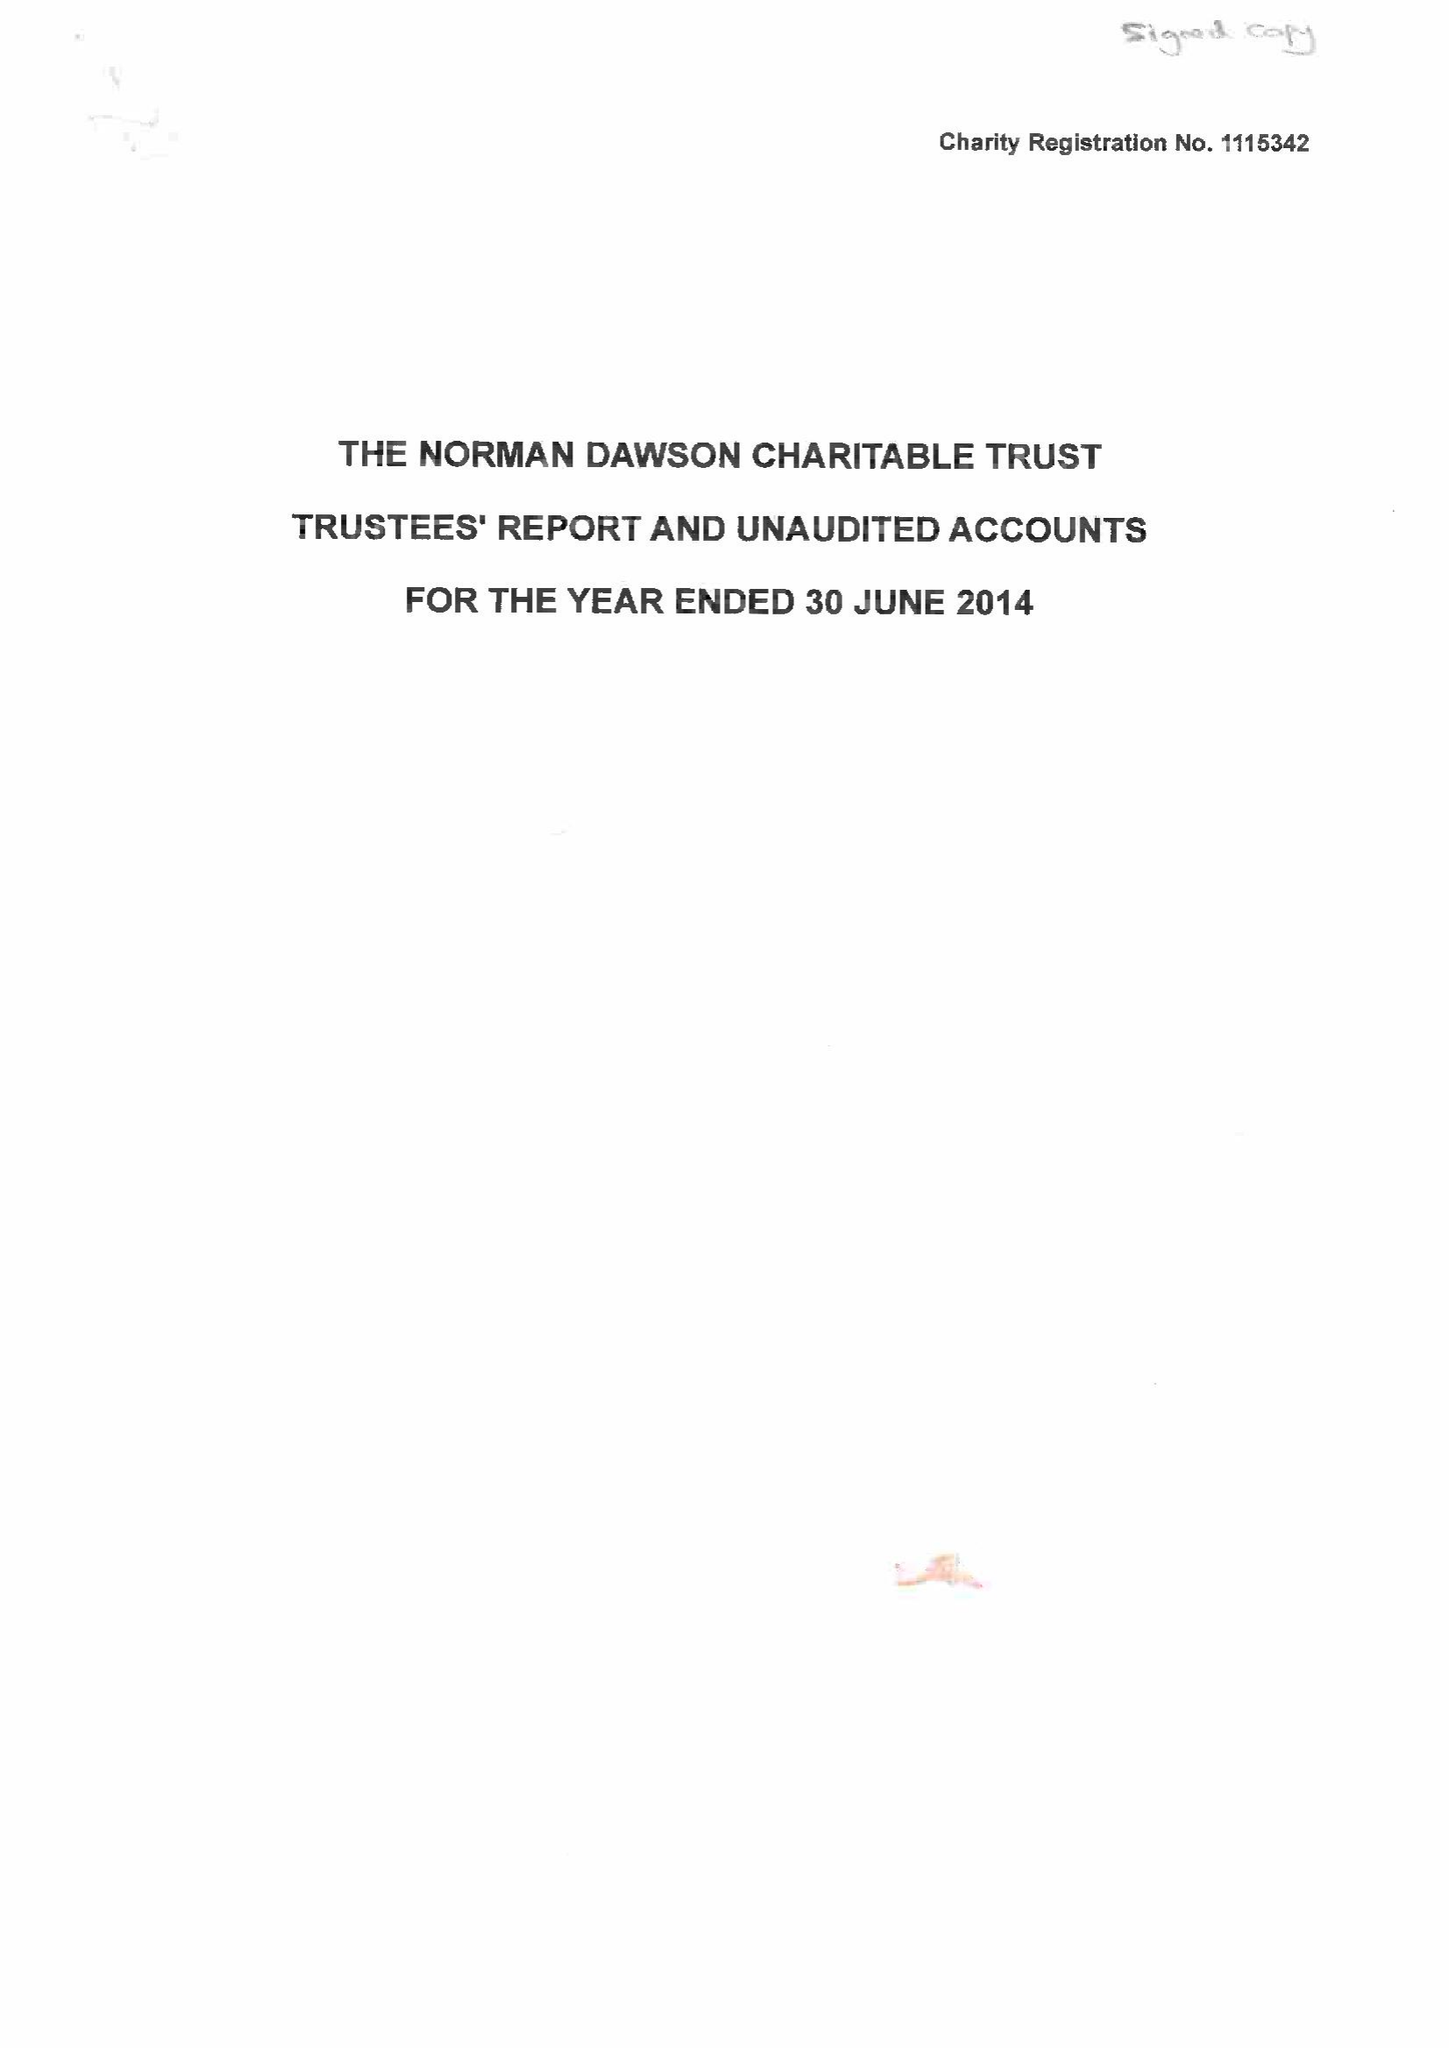What is the value for the income_annually_in_british_pounds?
Answer the question using a single word or phrase. 44453.00 